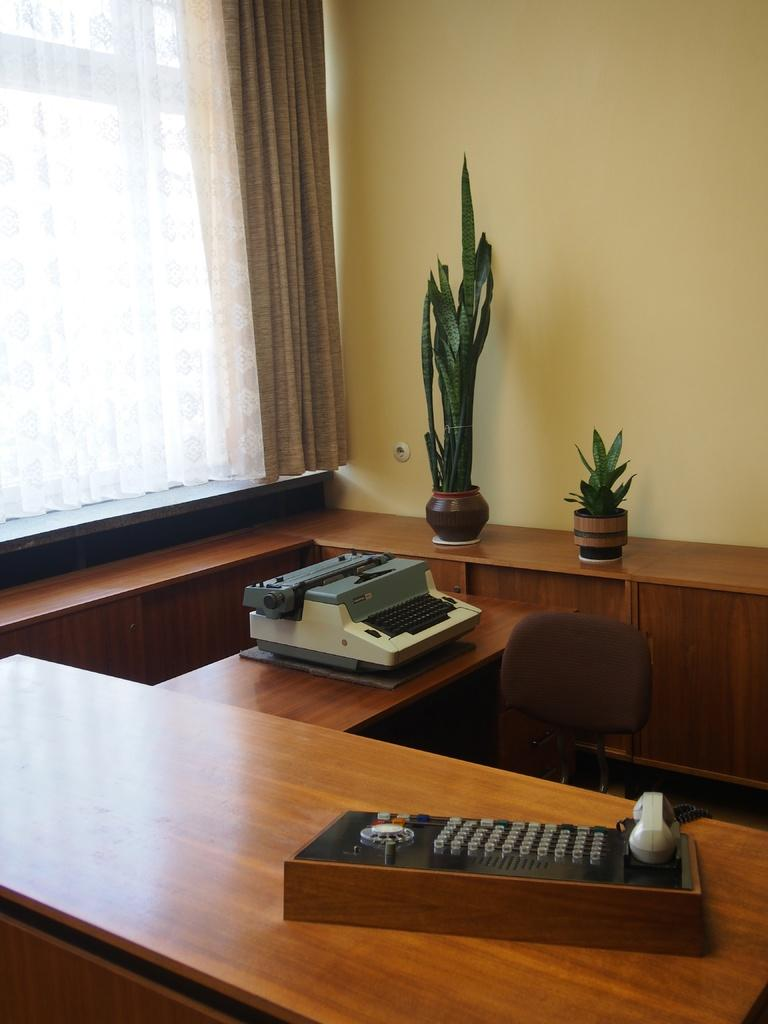What piece of furniture is in the image? There is a table in the image. What device is on the table? A printer is present on the table. What type of decorative items are on the table? There are flower pots on the table. What type of window treatment is visible in the image? There is a curtain in the image. What type of architectural feature is visible in the image? There is a wall visible in the image. Who is the creator of the spot on the wall in the image? There is no spot visible on the wall in the image. Can you tell me how fast the person is running in the image? There is no person running in the image. 